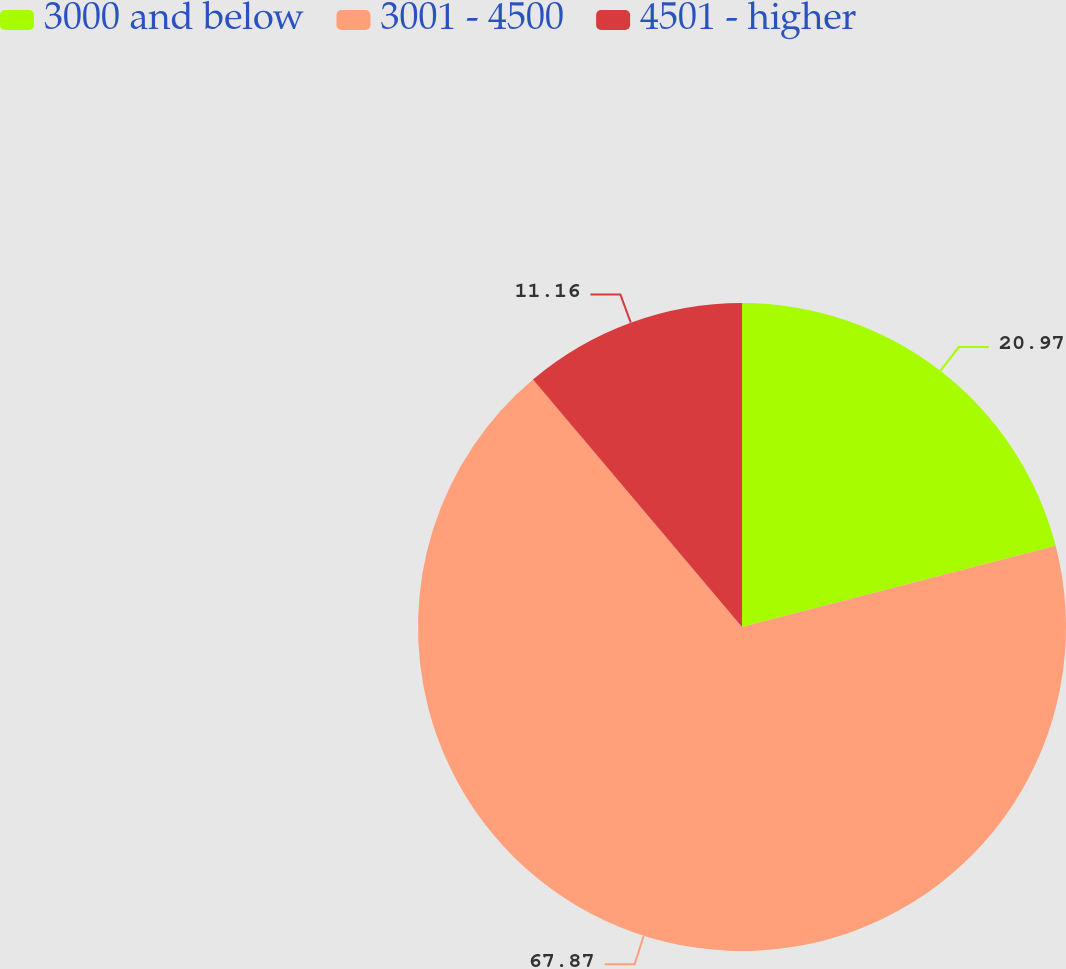Convert chart. <chart><loc_0><loc_0><loc_500><loc_500><pie_chart><fcel>3000 and below<fcel>3001 - 4500<fcel>4501 - higher<nl><fcel>20.97%<fcel>67.87%<fcel>11.16%<nl></chart> 